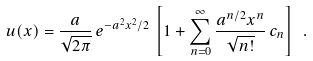Convert formula to latex. <formula><loc_0><loc_0><loc_500><loc_500>u ( x ) = \frac { a } { \sqrt { 2 \pi } } \, e ^ { - a ^ { 2 } x ^ { 2 } / 2 } \, \left [ 1 + \sum _ { n = 0 } ^ { \infty } \frac { a ^ { n / 2 } x ^ { n } } { \sqrt { n ! } } \, c _ { n } \right ] \ .</formula> 